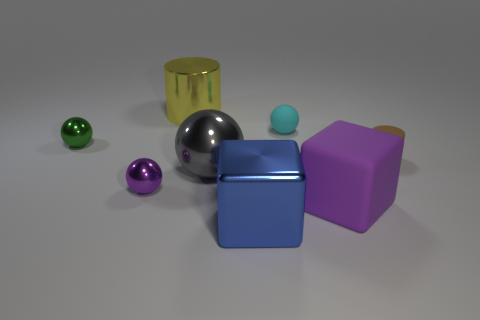Add 2 big purple things. How many objects exist? 10 Subtract all small balls. How many balls are left? 1 Subtract 1 cylinders. How many cylinders are left? 1 Subtract all cylinders. How many objects are left? 6 Add 6 blue shiny objects. How many blue shiny objects exist? 7 Subtract all purple blocks. How many blocks are left? 1 Subtract 1 gray spheres. How many objects are left? 7 Subtract all red cylinders. Subtract all gray cubes. How many cylinders are left? 2 Subtract all purple cylinders. How many blue blocks are left? 1 Subtract all big shiny balls. Subtract all tiny purple balls. How many objects are left? 6 